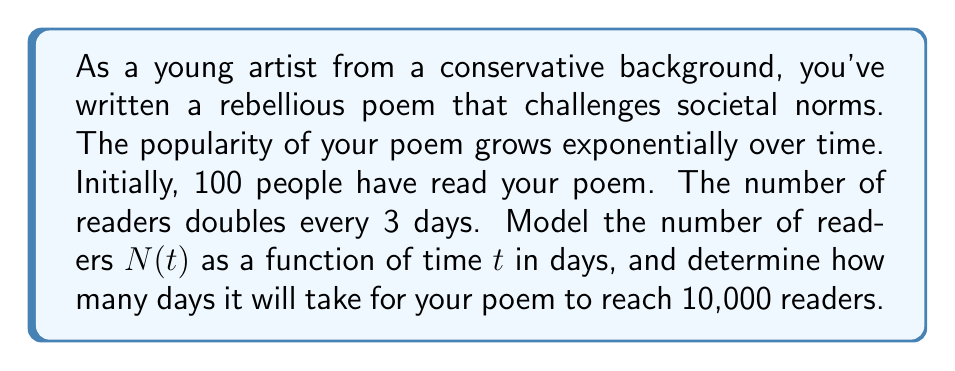Can you answer this question? Let's approach this step-by-step:

1) The general form of an exponential function is:
   $$N(t) = N_0 \cdot b^{t/k}$$
   where $N_0$ is the initial value, $b$ is the growth factor, $t$ is time, and $k$ is the time it takes for one growth cycle.

2) In this case:
   - $N_0 = 100$ (initial readers)
   - $b = 2$ (doubles each cycle)
   - $k = 3$ (3 days per cycle)

3) Substituting these values into our equation:
   $$N(t) = 100 \cdot 2^{t/3}$$

4) To find when the poem reaches 10,000 readers, we set up the equation:
   $$10000 = 100 \cdot 2^{t/3}$$

5) Divide both sides by 100:
   $$100 = 2^{t/3}$$

6) Take the logarithm (base 2) of both sides:
   $$\log_2(100) = \frac{t}{3}$$

7) Solve for $t$:
   $$t = 3 \cdot \log_2(100) \approx 19.93$$

8) Since we can't have a fractional day, we round up to the next whole day.
Answer: The number of readers after $t$ days can be modeled by the function $N(t) = 100 \cdot 2^{t/3}$. It will take 20 days for the poem to reach 10,000 readers. 